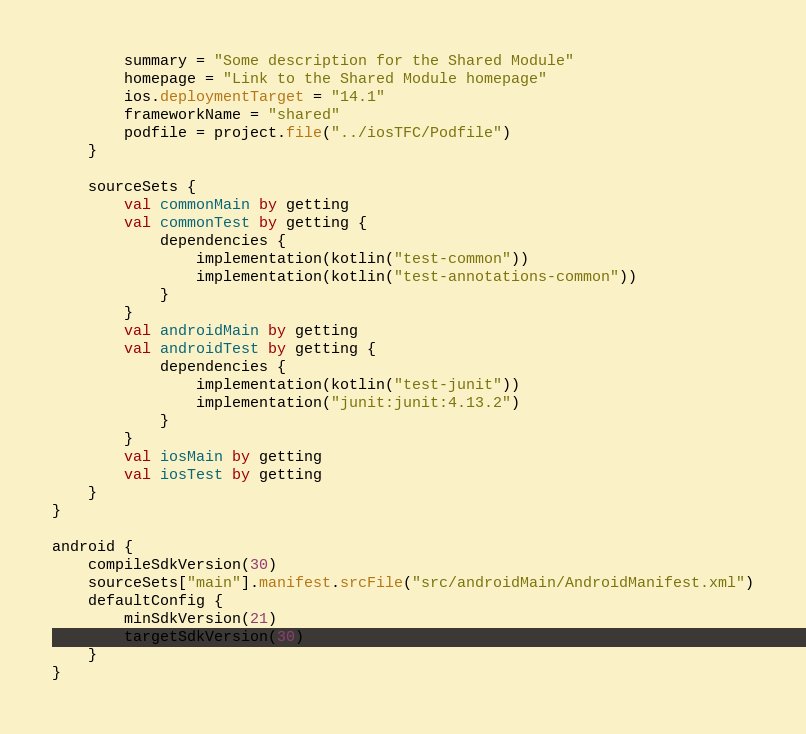<code> <loc_0><loc_0><loc_500><loc_500><_Kotlin_>        summary = "Some description for the Shared Module"
        homepage = "Link to the Shared Module homepage"
        ios.deploymentTarget = "14.1"
        frameworkName = "shared"
        podfile = project.file("../iosTFC/Podfile")
    }
    
    sourceSets {
        val commonMain by getting
        val commonTest by getting {
            dependencies {
                implementation(kotlin("test-common"))
                implementation(kotlin("test-annotations-common"))
            }
        }
        val androidMain by getting
        val androidTest by getting {
            dependencies {
                implementation(kotlin("test-junit"))
                implementation("junit:junit:4.13.2")
            }
        }
        val iosMain by getting
        val iosTest by getting
    }
}

android {
    compileSdkVersion(30)
    sourceSets["main"].manifest.srcFile("src/androidMain/AndroidManifest.xml")
    defaultConfig {
        minSdkVersion(21)
        targetSdkVersion(30)
    }
}</code> 